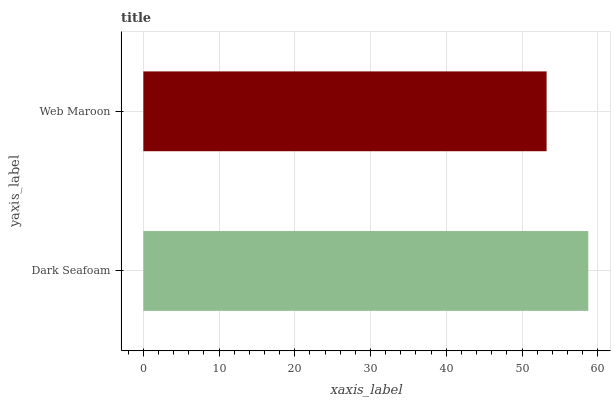Is Web Maroon the minimum?
Answer yes or no. Yes. Is Dark Seafoam the maximum?
Answer yes or no. Yes. Is Web Maroon the maximum?
Answer yes or no. No. Is Dark Seafoam greater than Web Maroon?
Answer yes or no. Yes. Is Web Maroon less than Dark Seafoam?
Answer yes or no. Yes. Is Web Maroon greater than Dark Seafoam?
Answer yes or no. No. Is Dark Seafoam less than Web Maroon?
Answer yes or no. No. Is Dark Seafoam the high median?
Answer yes or no. Yes. Is Web Maroon the low median?
Answer yes or no. Yes. Is Web Maroon the high median?
Answer yes or no. No. Is Dark Seafoam the low median?
Answer yes or no. No. 